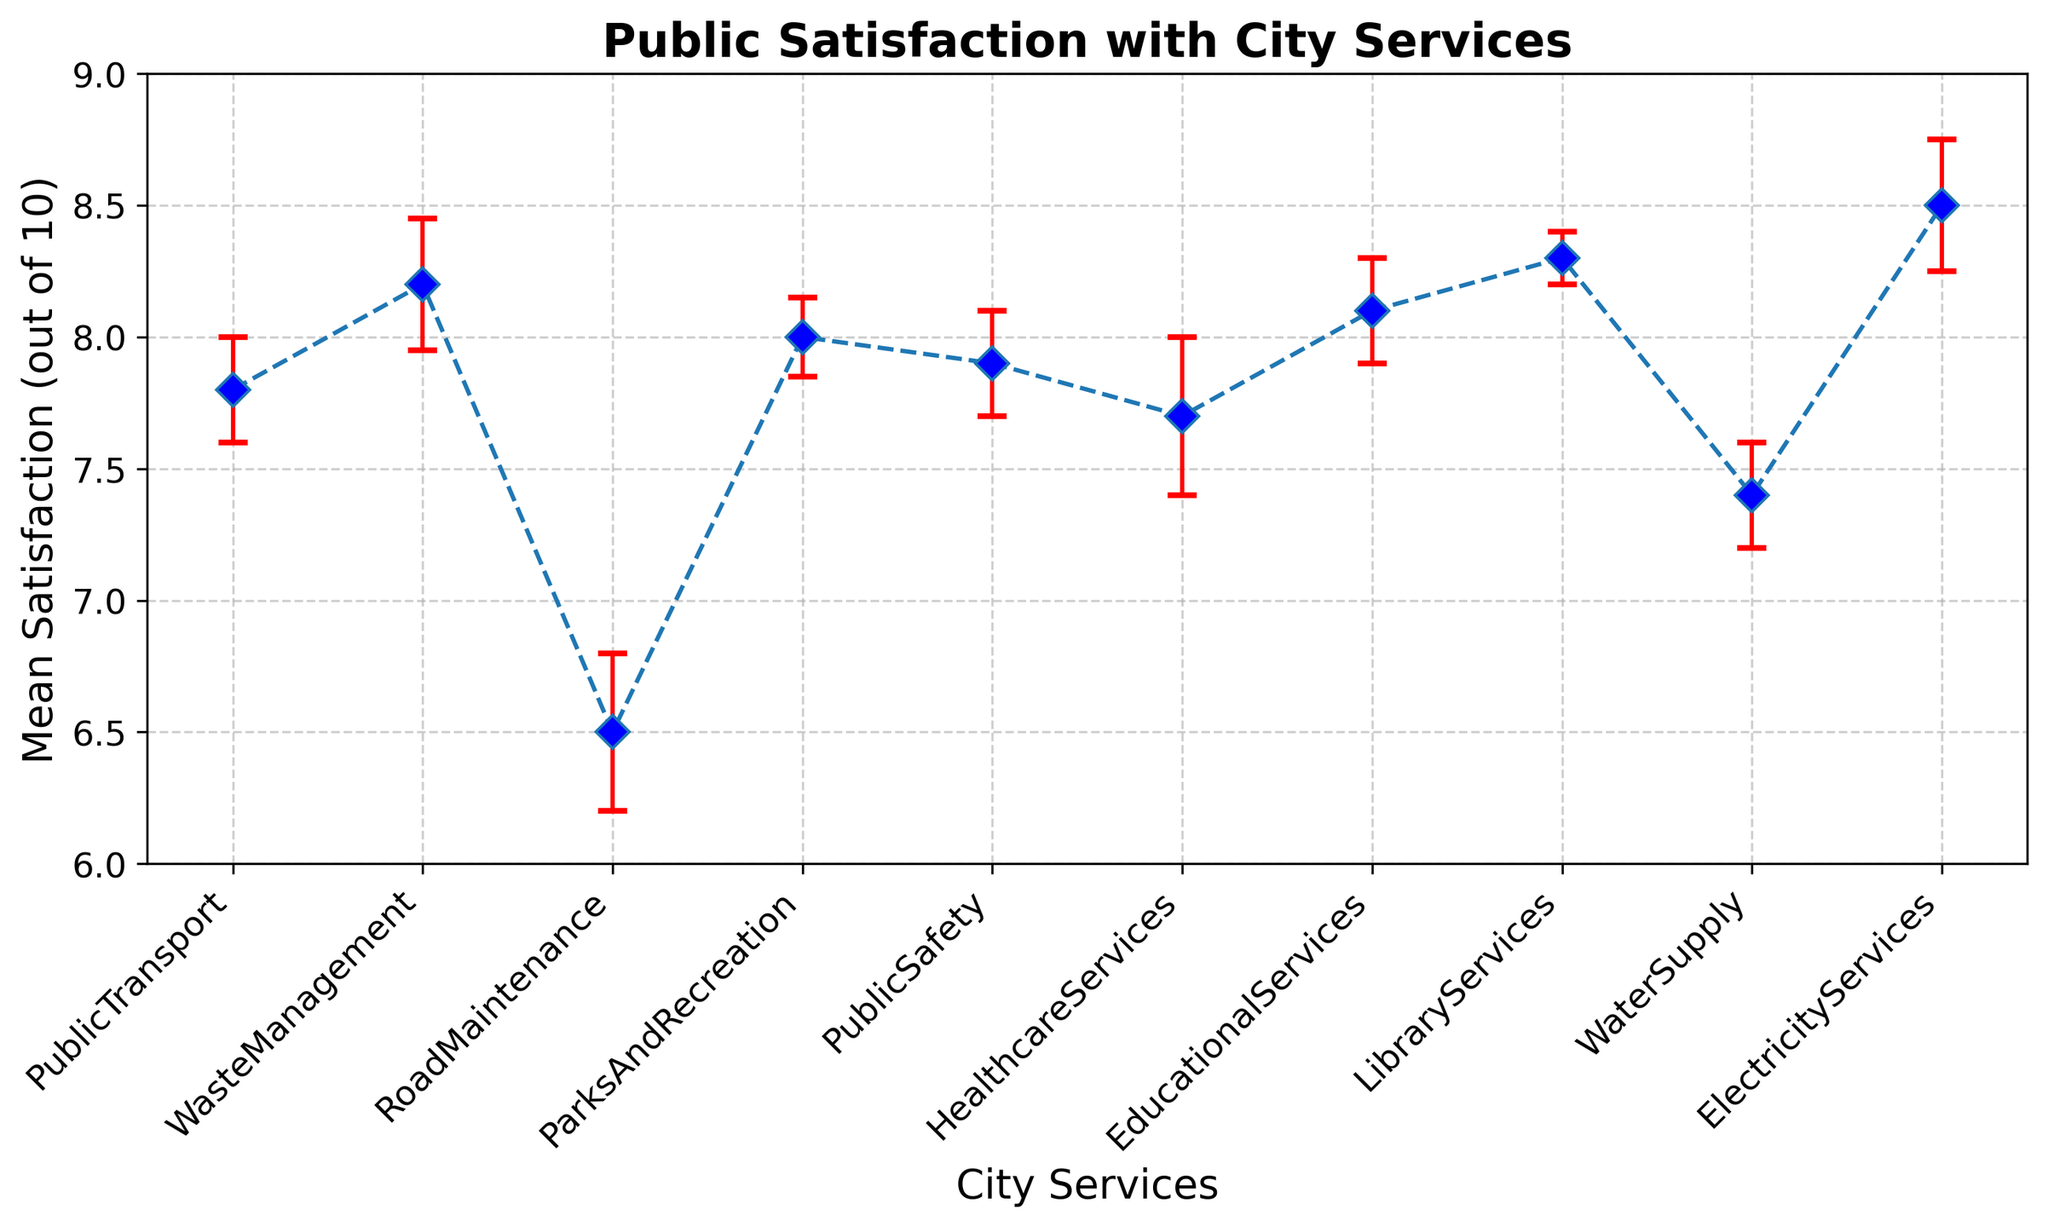What's the highest mean satisfaction score for a city service? Look for the service with the peak mean satisfaction score. The highest mean satisfaction score, which is the tallest point on the plot, corresponds to Electricity Services at 8.5.
Answer: Electricity Services at 8.5 What's the service with the lowest mean satisfaction score? Identify the service with the shortest point on the plot, representing the lowest mean satisfaction score. Road Maintenance has the lowest mean satisfaction score at 6.5.
Answer: Road Maintenance at 6.5 Are there any services with overlapping confidence intervals? Examine the red error bars; if any overlap, those confidence intervals are likely overlapping. Overlaps exist between Public Transport, Public Safety, and Healthcare Services around 7.7-7.9.
Answer: Public Transport, Public Safety, Healthcare Services What's the mean satisfaction difference between the highest and lowest services? Identify the highest (Electricity Services at 8.5) and lowest (Road Maintenance at 6.5) mean satisfaction scores, then subtract the latter from the former (8.5 - 6.5).
Answer: 2.0 Which services have a mean satisfaction score of 8 or higher? Identify the services on the plot where the mean satisfaction score is at least 8. This includes Waste Management, Educational Services, Library Services, and Electricity Services.
Answer: Waste Management, Educational Services, Library Services, Electricity Services What's the average mean satisfaction score across all services? Sum the mean satisfaction scores of all services and divide by the number of services. (7.8 + 8.2 + 6.5 + 8.0 + 7.9 + 7.7 + 8.1 + 8.3 + 7.4 + 8.5) / 10 = 78.4 / 10.
Answer: 7.84 Is the mean satisfaction for Healthcare Services within the confidence interval of Public Safety? The mean satisfaction for Healthcare Services is 7.7 with a standard error of 0.3, resulting in a confidence interval of 7.4 to 8.0. The mean satisfaction for Public Safety is 7.9, with a standard error of 0.2,  resulting in a confidence interval of 7.7 to 8.1. Since 7.7 is within 7.7 to 8.1, Healthcare falls within Public Safety's interval.
Answer: Yes Between Public Transport and Water Supply, which service has a lower mean satisfaction score? Compare the mean satisfaction scores of Public Transport (7.8) and Water Supply (7.4). Water Supply has the lower score.
Answer: Water Supply What's the combined mean satisfaction for Parks and Recreation and Library Services? Add the mean satisfaction scores of Parks and Recreation (8.0) and Library Services (8.3): 8.0 + 8.3.
Answer: 16.3 